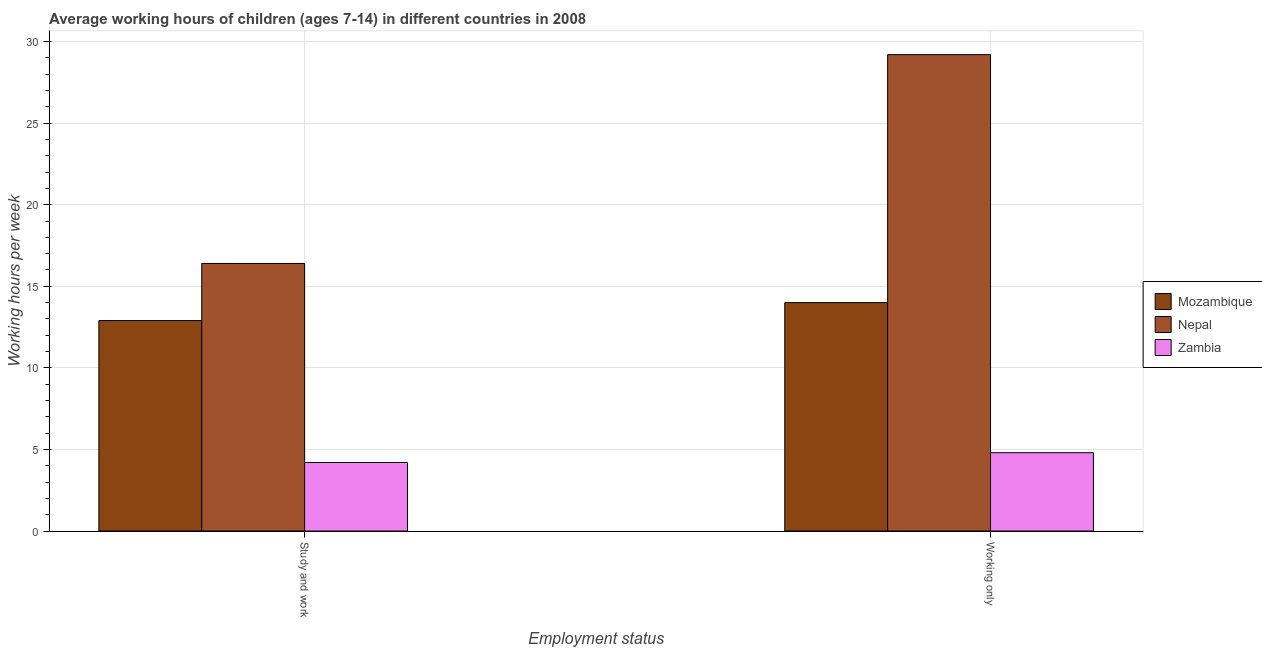Are the number of bars per tick equal to the number of legend labels?
Give a very brief answer. Yes. What is the label of the 2nd group of bars from the left?
Your response must be concise. Working only. What is the average working hour of children involved in study and work in Mozambique?
Make the answer very short. 12.9. In which country was the average working hour of children involved in only work maximum?
Offer a very short reply. Nepal. In which country was the average working hour of children involved in study and work minimum?
Make the answer very short. Zambia. What is the total average working hour of children involved in study and work in the graph?
Offer a terse response. 33.5. What is the difference between the average working hour of children involved in study and work in Mozambique and that in Nepal?
Offer a very short reply. -3.5. What is the difference between the average working hour of children involved in study and work in Mozambique and the average working hour of children involved in only work in Zambia?
Provide a succinct answer. 8.1. What is the average average working hour of children involved in study and work per country?
Give a very brief answer. 11.17. What is the difference between the average working hour of children involved in study and work and average working hour of children involved in only work in Mozambique?
Your answer should be very brief. -1.1. What is the ratio of the average working hour of children involved in only work in Mozambique to that in Zambia?
Your answer should be very brief. 2.92. Is the average working hour of children involved in study and work in Mozambique less than that in Zambia?
Your answer should be very brief. No. What does the 1st bar from the left in Study and work represents?
Keep it short and to the point. Mozambique. What does the 2nd bar from the right in Study and work represents?
Give a very brief answer. Nepal. How many countries are there in the graph?
Offer a terse response. 3. What is the difference between two consecutive major ticks on the Y-axis?
Your answer should be compact. 5. Are the values on the major ticks of Y-axis written in scientific E-notation?
Your answer should be compact. No. Does the graph contain any zero values?
Make the answer very short. No. How are the legend labels stacked?
Your answer should be compact. Vertical. What is the title of the graph?
Offer a terse response. Average working hours of children (ages 7-14) in different countries in 2008. Does "Zimbabwe" appear as one of the legend labels in the graph?
Your answer should be very brief. No. What is the label or title of the X-axis?
Give a very brief answer. Employment status. What is the label or title of the Y-axis?
Make the answer very short. Working hours per week. What is the Working hours per week in Mozambique in Study and work?
Provide a succinct answer. 12.9. What is the Working hours per week of Mozambique in Working only?
Keep it short and to the point. 14. What is the Working hours per week in Nepal in Working only?
Provide a succinct answer. 29.2. Across all Employment status, what is the maximum Working hours per week in Nepal?
Your response must be concise. 29.2. Across all Employment status, what is the minimum Working hours per week of Mozambique?
Your answer should be compact. 12.9. Across all Employment status, what is the minimum Working hours per week of Nepal?
Give a very brief answer. 16.4. What is the total Working hours per week in Mozambique in the graph?
Provide a short and direct response. 26.9. What is the total Working hours per week of Nepal in the graph?
Provide a succinct answer. 45.6. What is the total Working hours per week of Zambia in the graph?
Give a very brief answer. 9. What is the difference between the Working hours per week in Mozambique in Study and work and that in Working only?
Offer a very short reply. -1.1. What is the difference between the Working hours per week in Nepal in Study and work and that in Working only?
Your response must be concise. -12.8. What is the difference between the Working hours per week of Mozambique in Study and work and the Working hours per week of Nepal in Working only?
Provide a short and direct response. -16.3. What is the average Working hours per week in Mozambique per Employment status?
Ensure brevity in your answer.  13.45. What is the average Working hours per week in Nepal per Employment status?
Ensure brevity in your answer.  22.8. What is the average Working hours per week of Zambia per Employment status?
Your response must be concise. 4.5. What is the difference between the Working hours per week in Mozambique and Working hours per week in Zambia in Study and work?
Your response must be concise. 8.7. What is the difference between the Working hours per week in Mozambique and Working hours per week in Nepal in Working only?
Give a very brief answer. -15.2. What is the difference between the Working hours per week of Mozambique and Working hours per week of Zambia in Working only?
Make the answer very short. 9.2. What is the difference between the Working hours per week of Nepal and Working hours per week of Zambia in Working only?
Your answer should be compact. 24.4. What is the ratio of the Working hours per week of Mozambique in Study and work to that in Working only?
Offer a very short reply. 0.92. What is the ratio of the Working hours per week of Nepal in Study and work to that in Working only?
Keep it short and to the point. 0.56. What is the ratio of the Working hours per week in Zambia in Study and work to that in Working only?
Your answer should be very brief. 0.88. What is the difference between the highest and the second highest Working hours per week in Mozambique?
Your response must be concise. 1.1. What is the difference between the highest and the lowest Working hours per week of Mozambique?
Keep it short and to the point. 1.1. What is the difference between the highest and the lowest Working hours per week of Nepal?
Offer a very short reply. 12.8. What is the difference between the highest and the lowest Working hours per week of Zambia?
Provide a succinct answer. 0.6. 